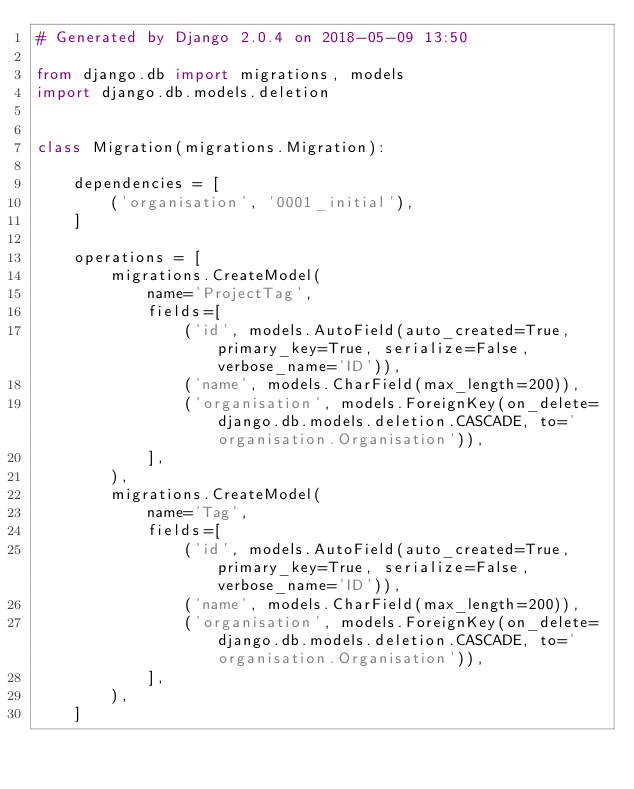<code> <loc_0><loc_0><loc_500><loc_500><_Python_># Generated by Django 2.0.4 on 2018-05-09 13:50

from django.db import migrations, models
import django.db.models.deletion


class Migration(migrations.Migration):

    dependencies = [
        ('organisation', '0001_initial'),
    ]

    operations = [
        migrations.CreateModel(
            name='ProjectTag',
            fields=[
                ('id', models.AutoField(auto_created=True, primary_key=True, serialize=False, verbose_name='ID')),
                ('name', models.CharField(max_length=200)),
                ('organisation', models.ForeignKey(on_delete=django.db.models.deletion.CASCADE, to='organisation.Organisation')),
            ],
        ),
        migrations.CreateModel(
            name='Tag',
            fields=[
                ('id', models.AutoField(auto_created=True, primary_key=True, serialize=False, verbose_name='ID')),
                ('name', models.CharField(max_length=200)),
                ('organisation', models.ForeignKey(on_delete=django.db.models.deletion.CASCADE, to='organisation.Organisation')),
            ],
        ),
    ]
</code> 